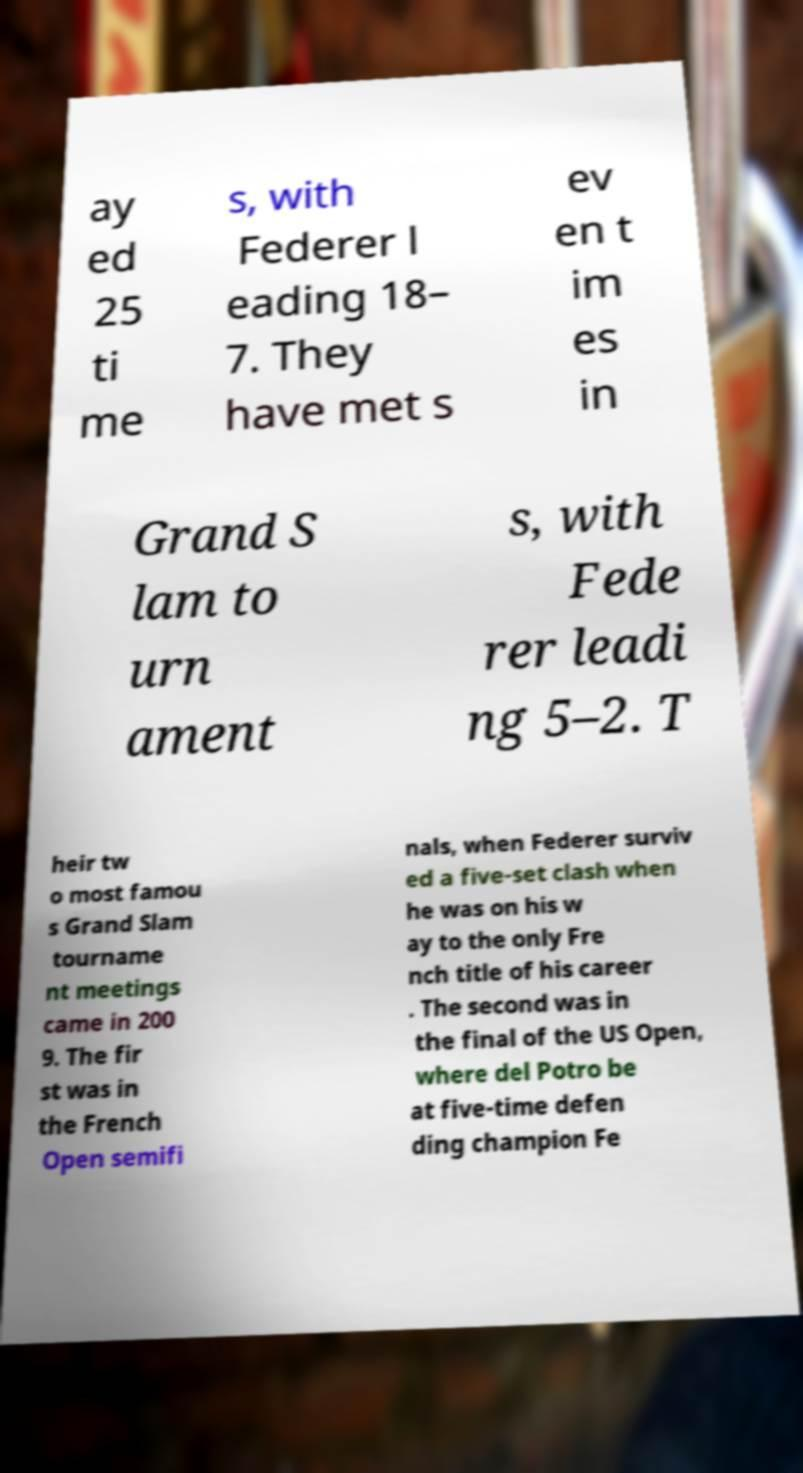Can you read and provide the text displayed in the image?This photo seems to have some interesting text. Can you extract and type it out for me? ay ed 25 ti me s, with Federer l eading 18– 7. They have met s ev en t im es in Grand S lam to urn ament s, with Fede rer leadi ng 5–2. T heir tw o most famou s Grand Slam tourname nt meetings came in 200 9. The fir st was in the French Open semifi nals, when Federer surviv ed a five-set clash when he was on his w ay to the only Fre nch title of his career . The second was in the final of the US Open, where del Potro be at five-time defen ding champion Fe 